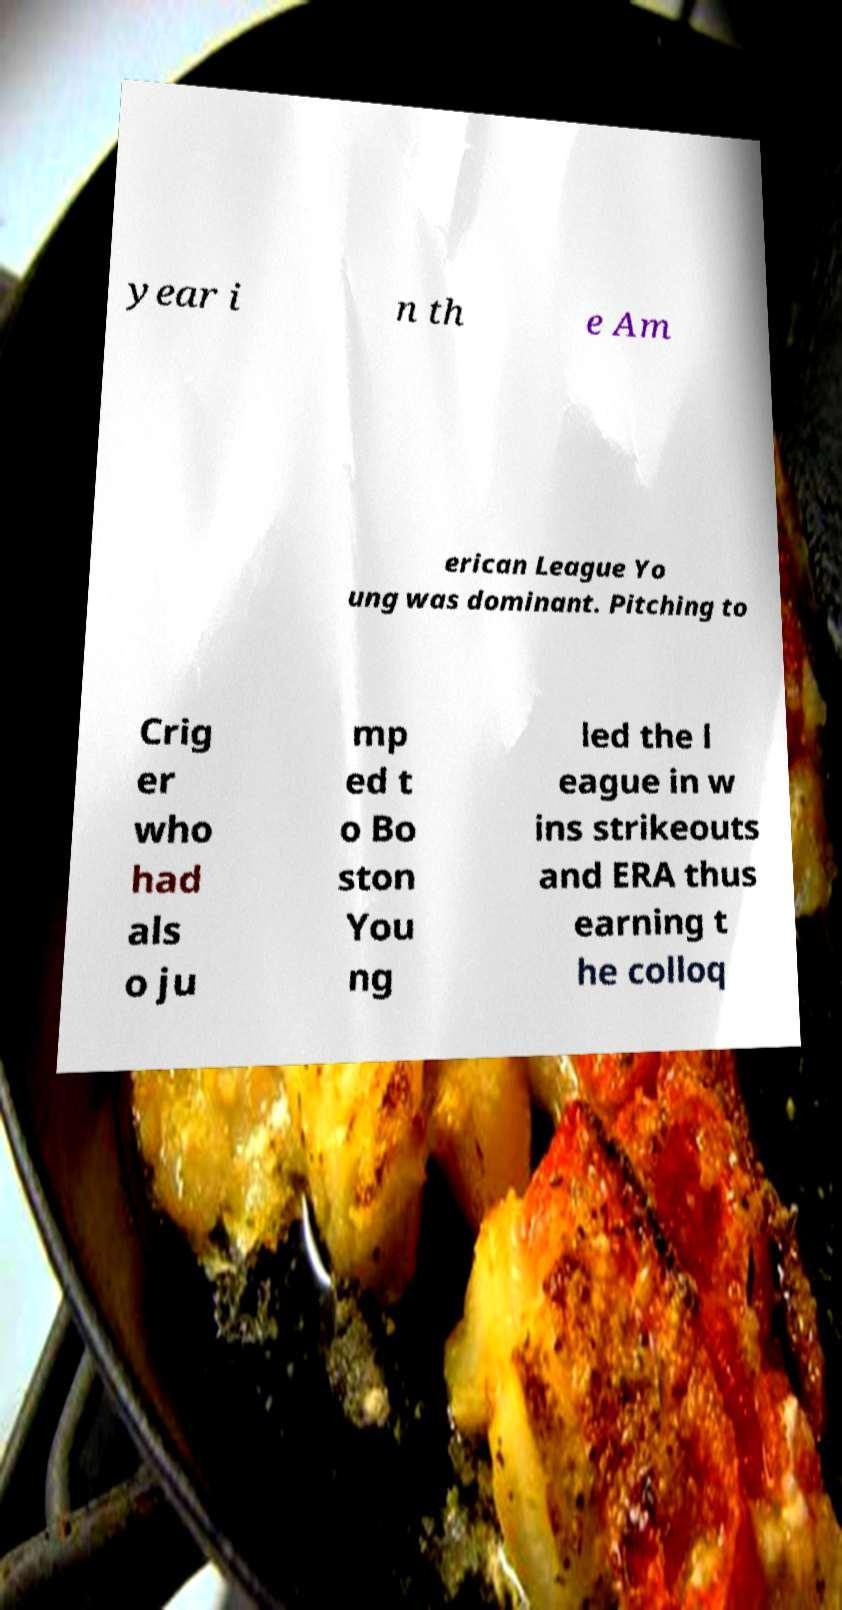What messages or text are displayed in this image? I need them in a readable, typed format. year i n th e Am erican League Yo ung was dominant. Pitching to Crig er who had als o ju mp ed t o Bo ston You ng led the l eague in w ins strikeouts and ERA thus earning t he colloq 